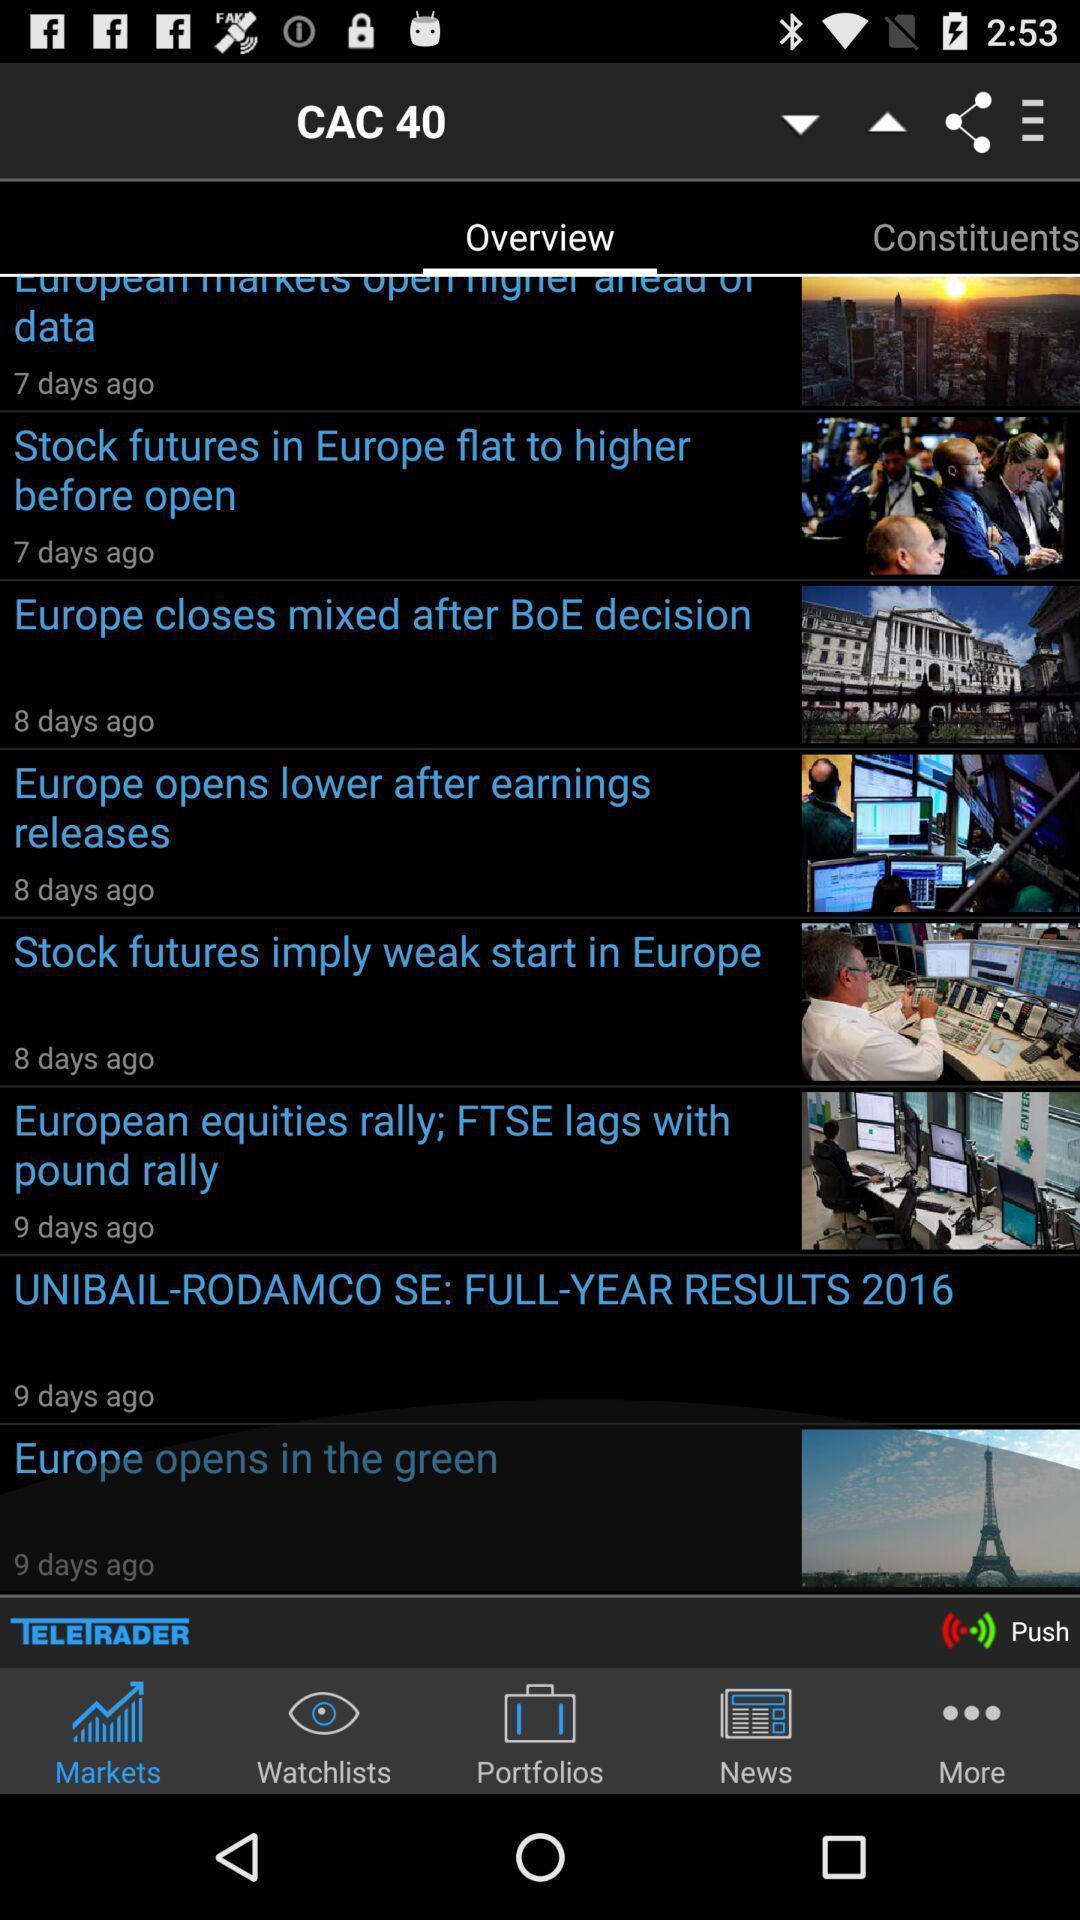What is the overall content of this screenshot? Screen displaying a list of recent articles on stock market. 